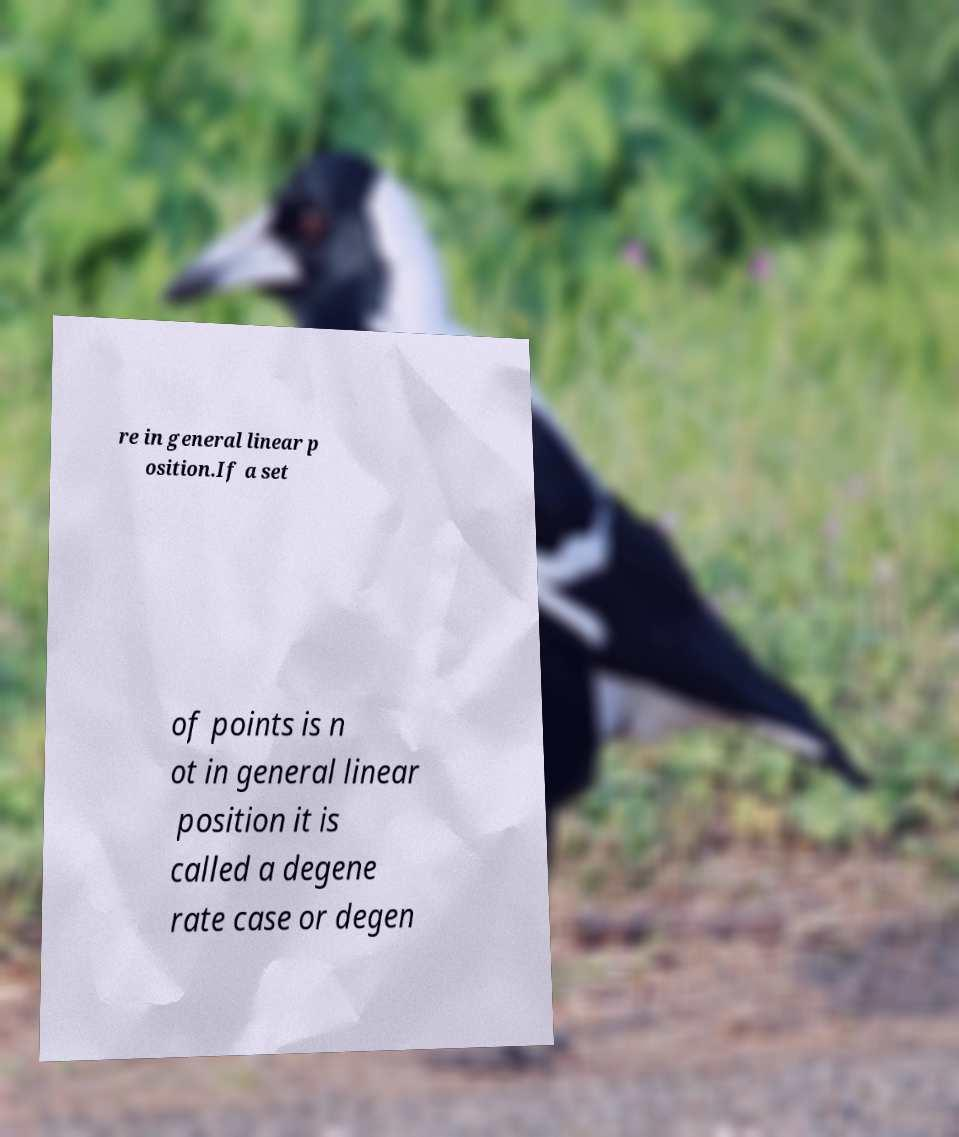Can you read and provide the text displayed in the image?This photo seems to have some interesting text. Can you extract and type it out for me? re in general linear p osition.If a set of points is n ot in general linear position it is called a degene rate case or degen 